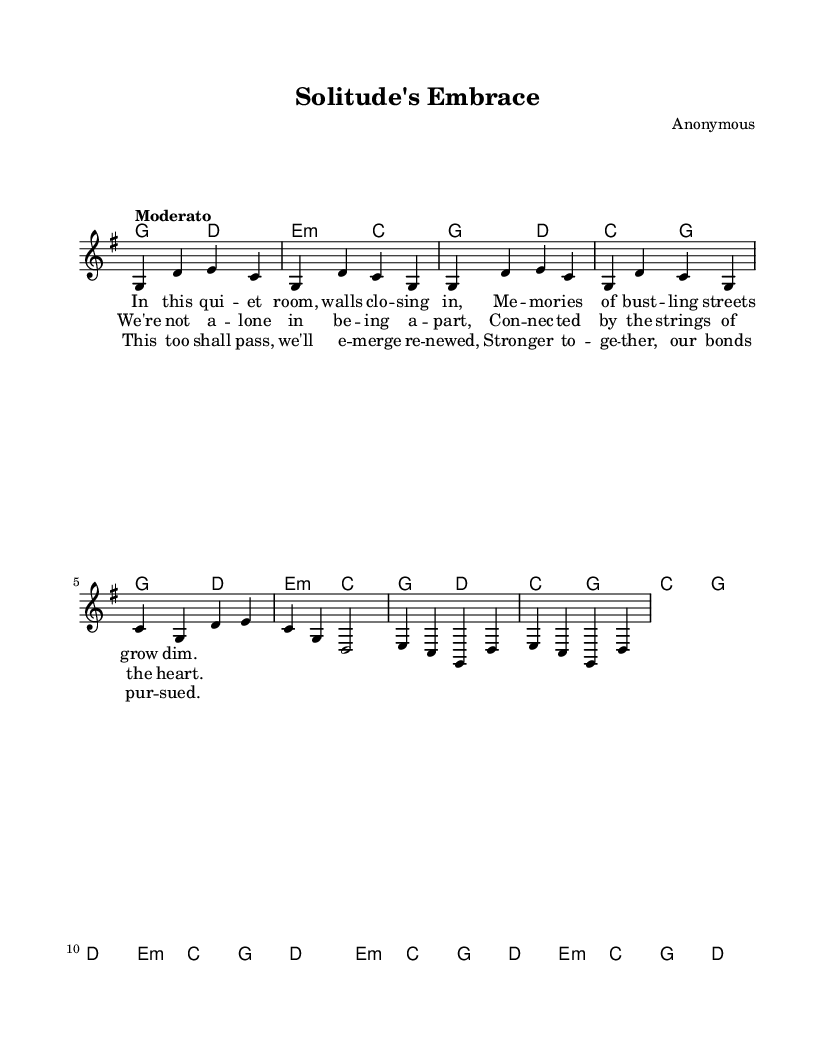What is the key signature of this music? The key signature is G major, which has one sharp (F#). It can be identified at the beginning of the staff where sharps and flats are denoted.
Answer: G major What is the time signature of this music? The time signature is 4/4, indicated at the beginning of the score which represents four beats per measure.
Answer: 4/4 What is the tempo marking for this piece? The tempo marking is "Moderato," which typically indicates a moderate speed. It is mentioned directly in the score.
Answer: Moderato What is the first chord in the piece? The first chord shown in the chord progressions is G major, which is identified in the harmonies section at the beginning.
Answer: G How many lines are there in the chorus lyrics? The chorus has four lines, and this can be counted visually in the lyrics section below the melody.
Answer: Four What themes are explored in the lyrics of this song? The lyrics explore themes of isolation and connection, as seen in phrases that refer to being apart yet connected. This is evident from the overall meaning of the text as interpreted from the lyrics.
Answer: Isolation and connection What is the last chord of the bridge? The last chord of the bridge is G major, which is determined by looking at the harmonies indicated under the bridge lyrics.
Answer: G 